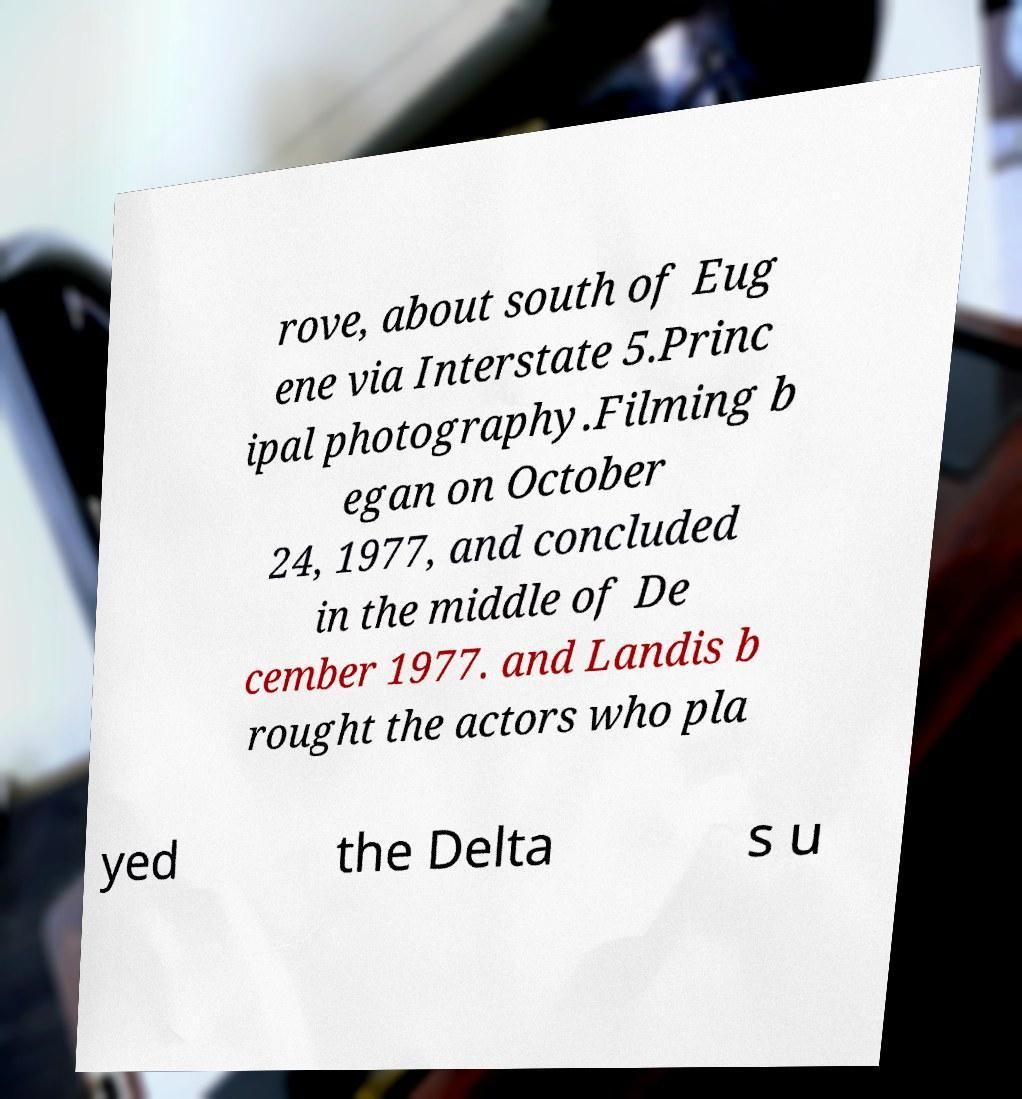Please read and relay the text visible in this image. What does it say? rove, about south of Eug ene via Interstate 5.Princ ipal photography.Filming b egan on October 24, 1977, and concluded in the middle of De cember 1977. and Landis b rought the actors who pla yed the Delta s u 